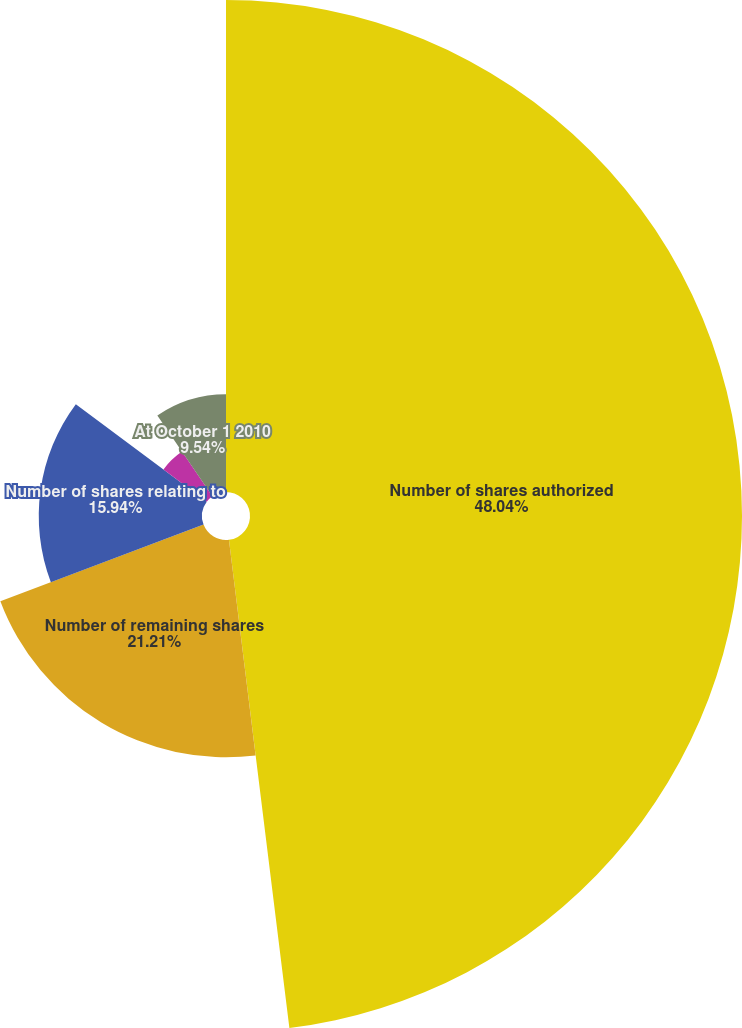<chart> <loc_0><loc_0><loc_500><loc_500><pie_chart><fcel>Number of shares authorized<fcel>Number of remaining shares<fcel>Number of shares relating to<fcel>At September 30 2011<fcel>At October 1 2010<nl><fcel>48.04%<fcel>21.21%<fcel>15.94%<fcel>5.27%<fcel>9.54%<nl></chart> 